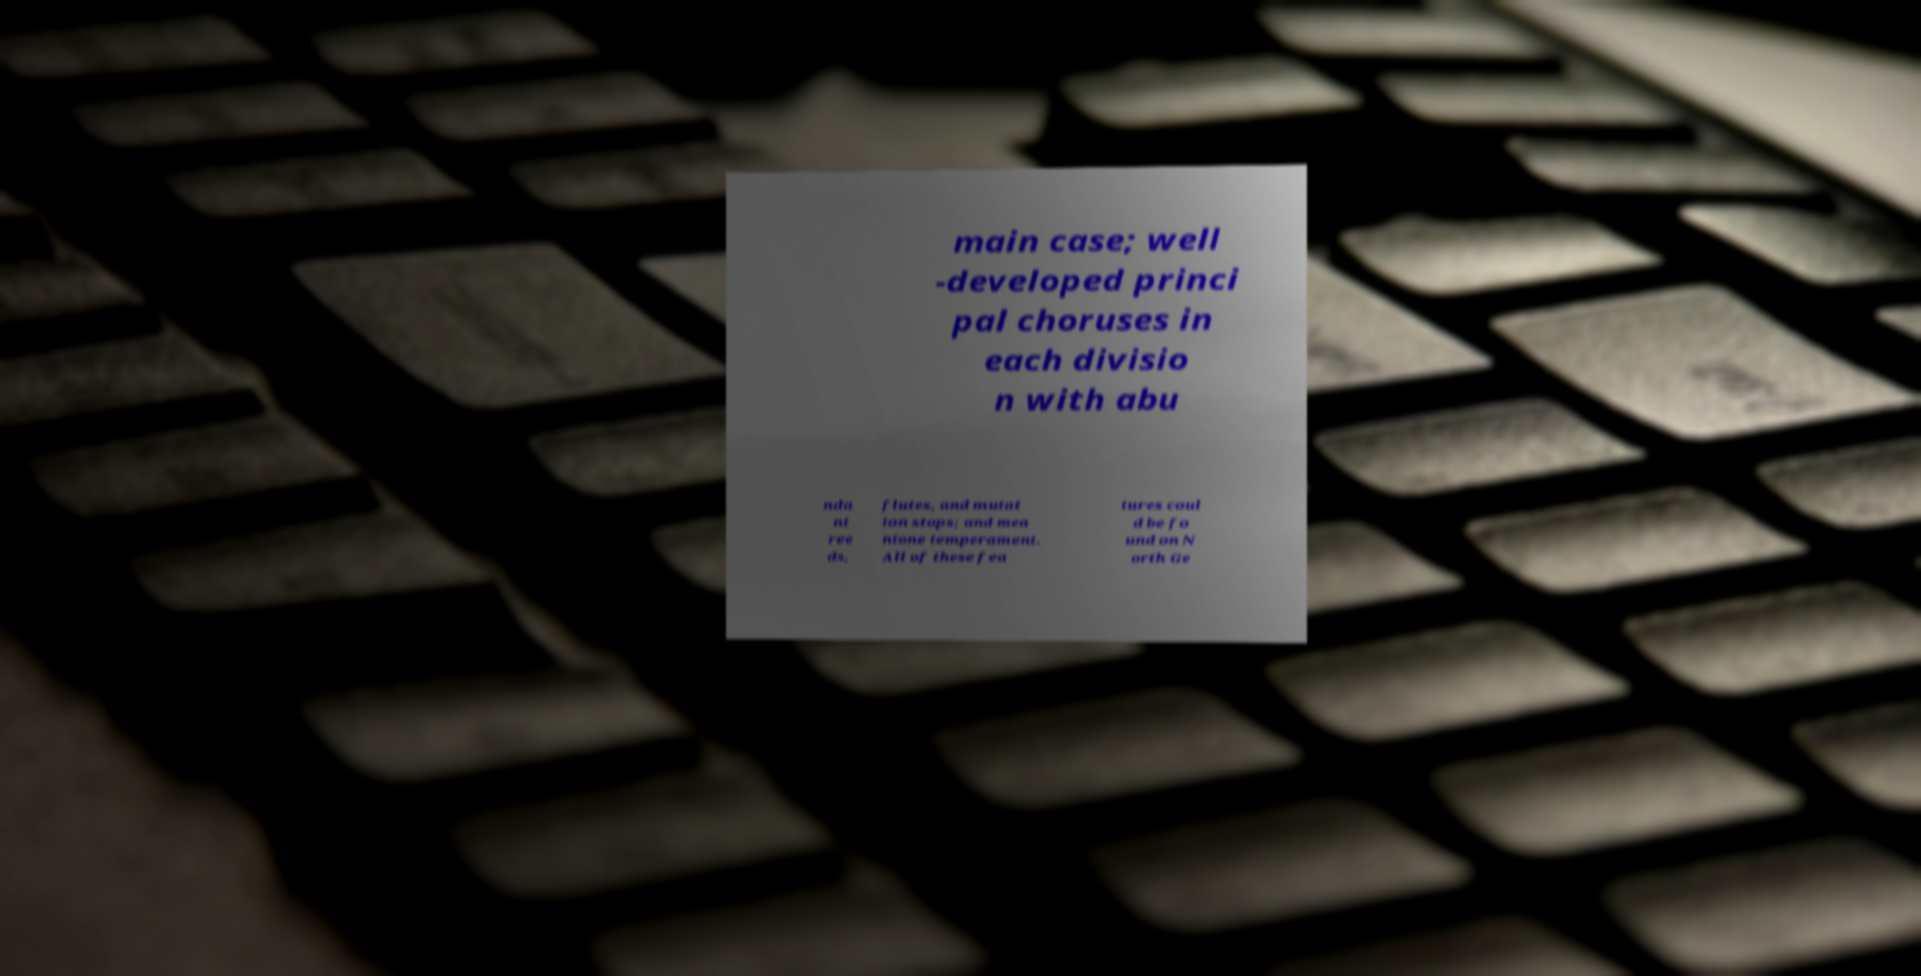Can you accurately transcribe the text from the provided image for me? main case; well -developed princi pal choruses in each divisio n with abu nda nt ree ds, flutes, and mutat ion stops; and mea ntone temperament. All of these fea tures coul d be fo und on N orth Ge 